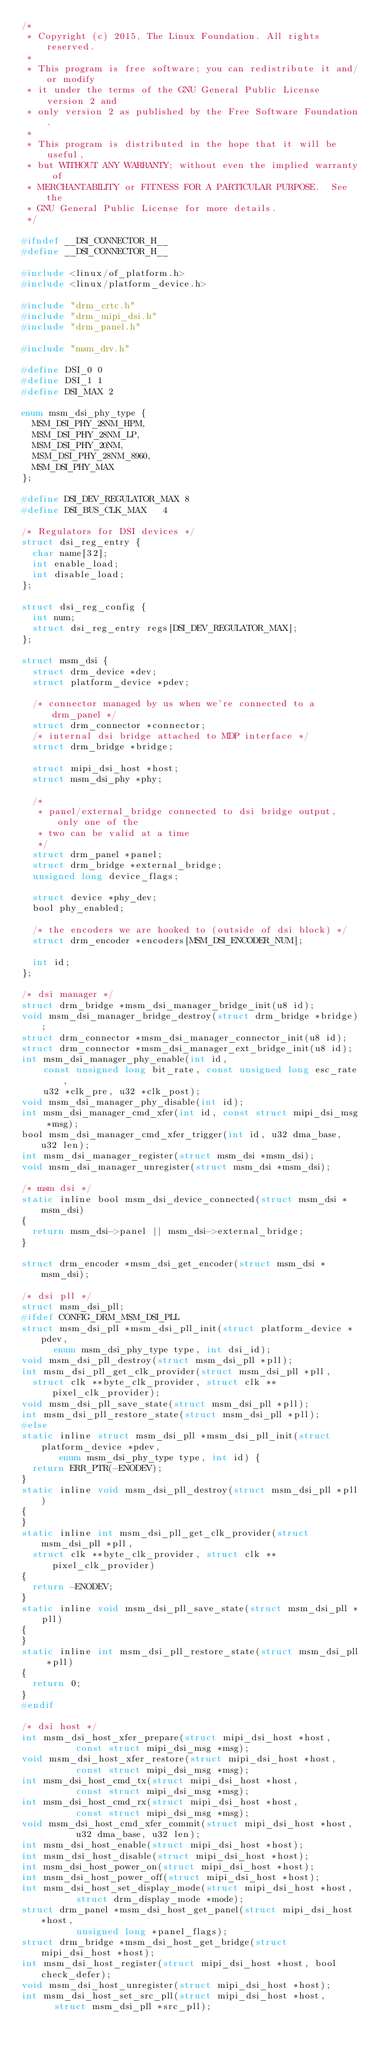<code> <loc_0><loc_0><loc_500><loc_500><_C_>/*
 * Copyright (c) 2015, The Linux Foundation. All rights reserved.
 *
 * This program is free software; you can redistribute it and/or modify
 * it under the terms of the GNU General Public License version 2 and
 * only version 2 as published by the Free Software Foundation.
 *
 * This program is distributed in the hope that it will be useful,
 * but WITHOUT ANY WARRANTY; without even the implied warranty of
 * MERCHANTABILITY or FITNESS FOR A PARTICULAR PURPOSE.  See the
 * GNU General Public License for more details.
 */

#ifndef __DSI_CONNECTOR_H__
#define __DSI_CONNECTOR_H__

#include <linux/of_platform.h>
#include <linux/platform_device.h>

#include "drm_crtc.h"
#include "drm_mipi_dsi.h"
#include "drm_panel.h"

#include "msm_drv.h"

#define DSI_0	0
#define DSI_1	1
#define DSI_MAX	2

enum msm_dsi_phy_type {
	MSM_DSI_PHY_28NM_HPM,
	MSM_DSI_PHY_28NM_LP,
	MSM_DSI_PHY_20NM,
	MSM_DSI_PHY_28NM_8960,
	MSM_DSI_PHY_MAX
};

#define DSI_DEV_REGULATOR_MAX	8
#define DSI_BUS_CLK_MAX		4

/* Regulators for DSI devices */
struct dsi_reg_entry {
	char name[32];
	int enable_load;
	int disable_load;
};

struct dsi_reg_config {
	int num;
	struct dsi_reg_entry regs[DSI_DEV_REGULATOR_MAX];
};

struct msm_dsi {
	struct drm_device *dev;
	struct platform_device *pdev;

	/* connector managed by us when we're connected to a drm_panel */
	struct drm_connector *connector;
	/* internal dsi bridge attached to MDP interface */
	struct drm_bridge *bridge;

	struct mipi_dsi_host *host;
	struct msm_dsi_phy *phy;

	/*
	 * panel/external_bridge connected to dsi bridge output, only one of the
	 * two can be valid at a time
	 */
	struct drm_panel *panel;
	struct drm_bridge *external_bridge;
	unsigned long device_flags;

	struct device *phy_dev;
	bool phy_enabled;

	/* the encoders we are hooked to (outside of dsi block) */
	struct drm_encoder *encoders[MSM_DSI_ENCODER_NUM];

	int id;
};

/* dsi manager */
struct drm_bridge *msm_dsi_manager_bridge_init(u8 id);
void msm_dsi_manager_bridge_destroy(struct drm_bridge *bridge);
struct drm_connector *msm_dsi_manager_connector_init(u8 id);
struct drm_connector *msm_dsi_manager_ext_bridge_init(u8 id);
int msm_dsi_manager_phy_enable(int id,
		const unsigned long bit_rate, const unsigned long esc_rate,
		u32 *clk_pre, u32 *clk_post);
void msm_dsi_manager_phy_disable(int id);
int msm_dsi_manager_cmd_xfer(int id, const struct mipi_dsi_msg *msg);
bool msm_dsi_manager_cmd_xfer_trigger(int id, u32 dma_base, u32 len);
int msm_dsi_manager_register(struct msm_dsi *msm_dsi);
void msm_dsi_manager_unregister(struct msm_dsi *msm_dsi);

/* msm dsi */
static inline bool msm_dsi_device_connected(struct msm_dsi *msm_dsi)
{
	return msm_dsi->panel || msm_dsi->external_bridge;
}

struct drm_encoder *msm_dsi_get_encoder(struct msm_dsi *msm_dsi);

/* dsi pll */
struct msm_dsi_pll;
#ifdef CONFIG_DRM_MSM_DSI_PLL
struct msm_dsi_pll *msm_dsi_pll_init(struct platform_device *pdev,
			enum msm_dsi_phy_type type, int dsi_id);
void msm_dsi_pll_destroy(struct msm_dsi_pll *pll);
int msm_dsi_pll_get_clk_provider(struct msm_dsi_pll *pll,
	struct clk **byte_clk_provider, struct clk **pixel_clk_provider);
void msm_dsi_pll_save_state(struct msm_dsi_pll *pll);
int msm_dsi_pll_restore_state(struct msm_dsi_pll *pll);
#else
static inline struct msm_dsi_pll *msm_dsi_pll_init(struct platform_device *pdev,
			 enum msm_dsi_phy_type type, int id) {
	return ERR_PTR(-ENODEV);
}
static inline void msm_dsi_pll_destroy(struct msm_dsi_pll *pll)
{
}
static inline int msm_dsi_pll_get_clk_provider(struct msm_dsi_pll *pll,
	struct clk **byte_clk_provider, struct clk **pixel_clk_provider)
{
	return -ENODEV;
}
static inline void msm_dsi_pll_save_state(struct msm_dsi_pll *pll)
{
}
static inline int msm_dsi_pll_restore_state(struct msm_dsi_pll *pll)
{
	return 0;
}
#endif

/* dsi host */
int msm_dsi_host_xfer_prepare(struct mipi_dsi_host *host,
					const struct mipi_dsi_msg *msg);
void msm_dsi_host_xfer_restore(struct mipi_dsi_host *host,
					const struct mipi_dsi_msg *msg);
int msm_dsi_host_cmd_tx(struct mipi_dsi_host *host,
					const struct mipi_dsi_msg *msg);
int msm_dsi_host_cmd_rx(struct mipi_dsi_host *host,
					const struct mipi_dsi_msg *msg);
void msm_dsi_host_cmd_xfer_commit(struct mipi_dsi_host *host,
					u32 dma_base, u32 len);
int msm_dsi_host_enable(struct mipi_dsi_host *host);
int msm_dsi_host_disable(struct mipi_dsi_host *host);
int msm_dsi_host_power_on(struct mipi_dsi_host *host);
int msm_dsi_host_power_off(struct mipi_dsi_host *host);
int msm_dsi_host_set_display_mode(struct mipi_dsi_host *host,
					struct drm_display_mode *mode);
struct drm_panel *msm_dsi_host_get_panel(struct mipi_dsi_host *host,
					unsigned long *panel_flags);
struct drm_bridge *msm_dsi_host_get_bridge(struct mipi_dsi_host *host);
int msm_dsi_host_register(struct mipi_dsi_host *host, bool check_defer);
void msm_dsi_host_unregister(struct mipi_dsi_host *host);
int msm_dsi_host_set_src_pll(struct mipi_dsi_host *host,
			struct msm_dsi_pll *src_pll);</code> 